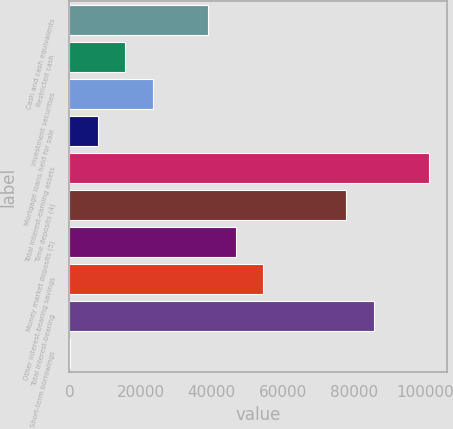<chart> <loc_0><loc_0><loc_500><loc_500><bar_chart><fcel>Cash and cash equivalents<fcel>Restricted cash<fcel>Investment securities<fcel>Mortgage loans held for sale<fcel>Total interest-earning assets<fcel>Time deposits (4)<fcel>Money market deposits (5)<fcel>Other interest-bearing savings<fcel>Total interest-bearing<fcel>Short-term borrowings<nl><fcel>38977.5<fcel>15657.6<fcel>23430.9<fcel>7884.3<fcel>101164<fcel>77844<fcel>46750.8<fcel>54524.1<fcel>85617.3<fcel>111<nl></chart> 